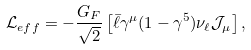Convert formula to latex. <formula><loc_0><loc_0><loc_500><loc_500>\mathcal { L } _ { e f f } = - \frac { G _ { F } } { \sqrt { 2 } } \left [ \bar { \ell } \gamma ^ { \mu } ( 1 - \gamma ^ { 5 } ) \nu _ { \ell } \mathcal { J } _ { \mu } \right ] ,</formula> 